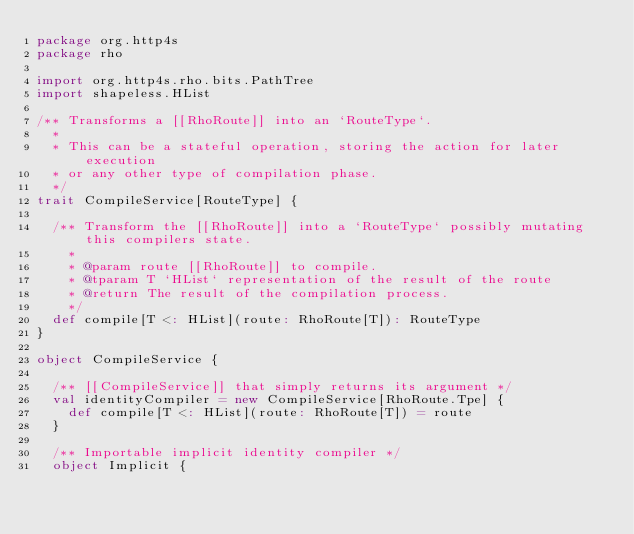Convert code to text. <code><loc_0><loc_0><loc_500><loc_500><_Scala_>package org.http4s
package rho

import org.http4s.rho.bits.PathTree
import shapeless.HList

/** Transforms a [[RhoRoute]] into an `RouteType`.
  *
  * This can be a stateful operation, storing the action for later execution
  * or any other type of compilation phase.
  */
trait CompileService[RouteType] {

  /** Transform the [[RhoRoute]] into a `RouteType` possibly mutating this compilers state.
    *
    * @param route [[RhoRoute]] to compile.
    * @tparam T `HList` representation of the result of the route
    * @return The result of the compilation process.
    */
  def compile[T <: HList](route: RhoRoute[T]): RouteType
}

object CompileService {

  /** [[CompileService]] that simply returns its argument */
  val identityCompiler = new CompileService[RhoRoute.Tpe] {
    def compile[T <: HList](route: RhoRoute[T]) = route
  }

  /** Importable implicit identity compiler */
  object Implicit {</code> 